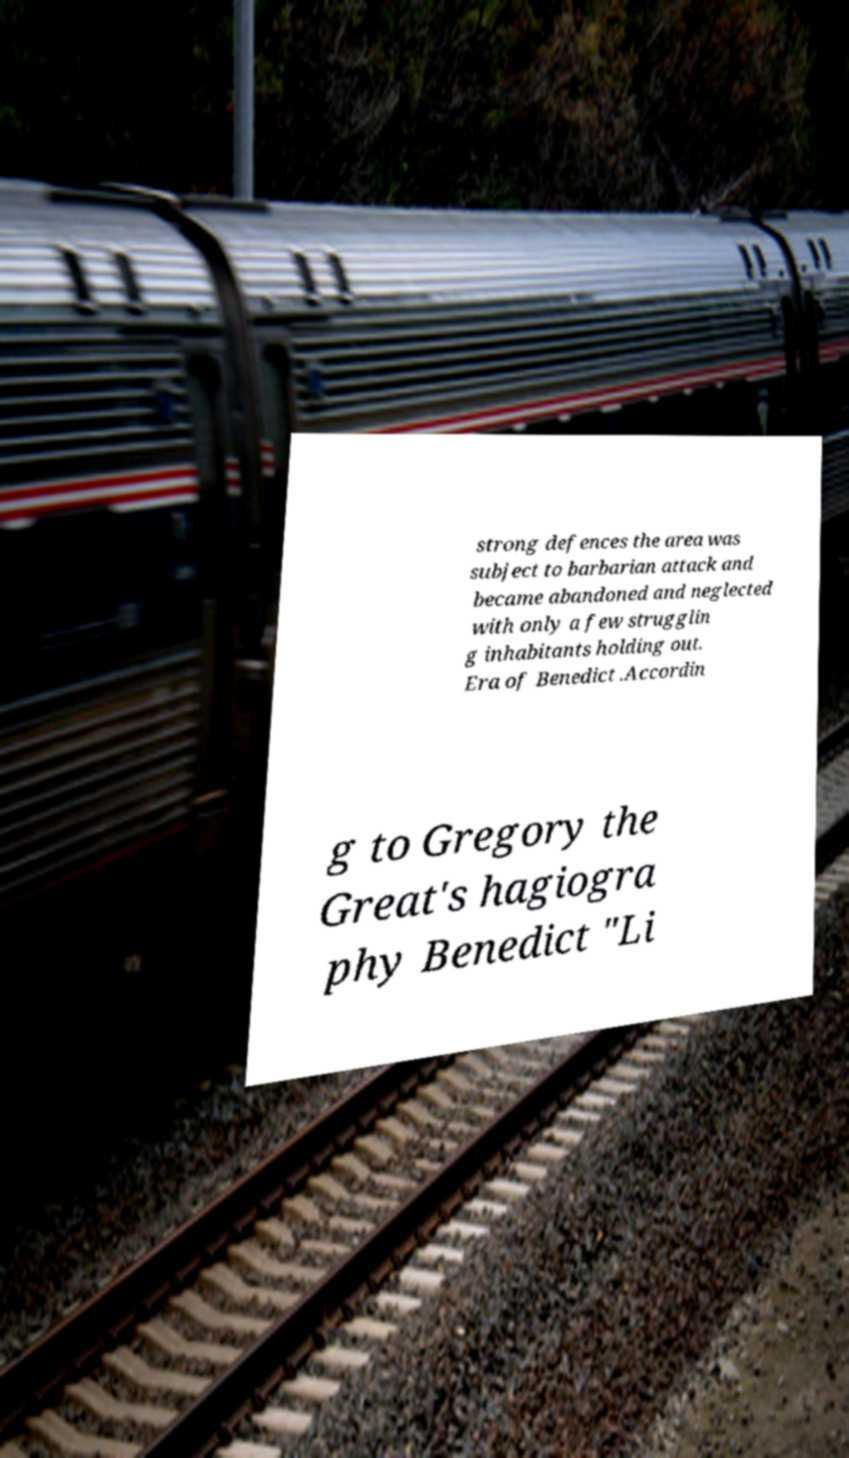There's text embedded in this image that I need extracted. Can you transcribe it verbatim? strong defences the area was subject to barbarian attack and became abandoned and neglected with only a few strugglin g inhabitants holding out. Era of Benedict .Accordin g to Gregory the Great's hagiogra phy Benedict "Li 